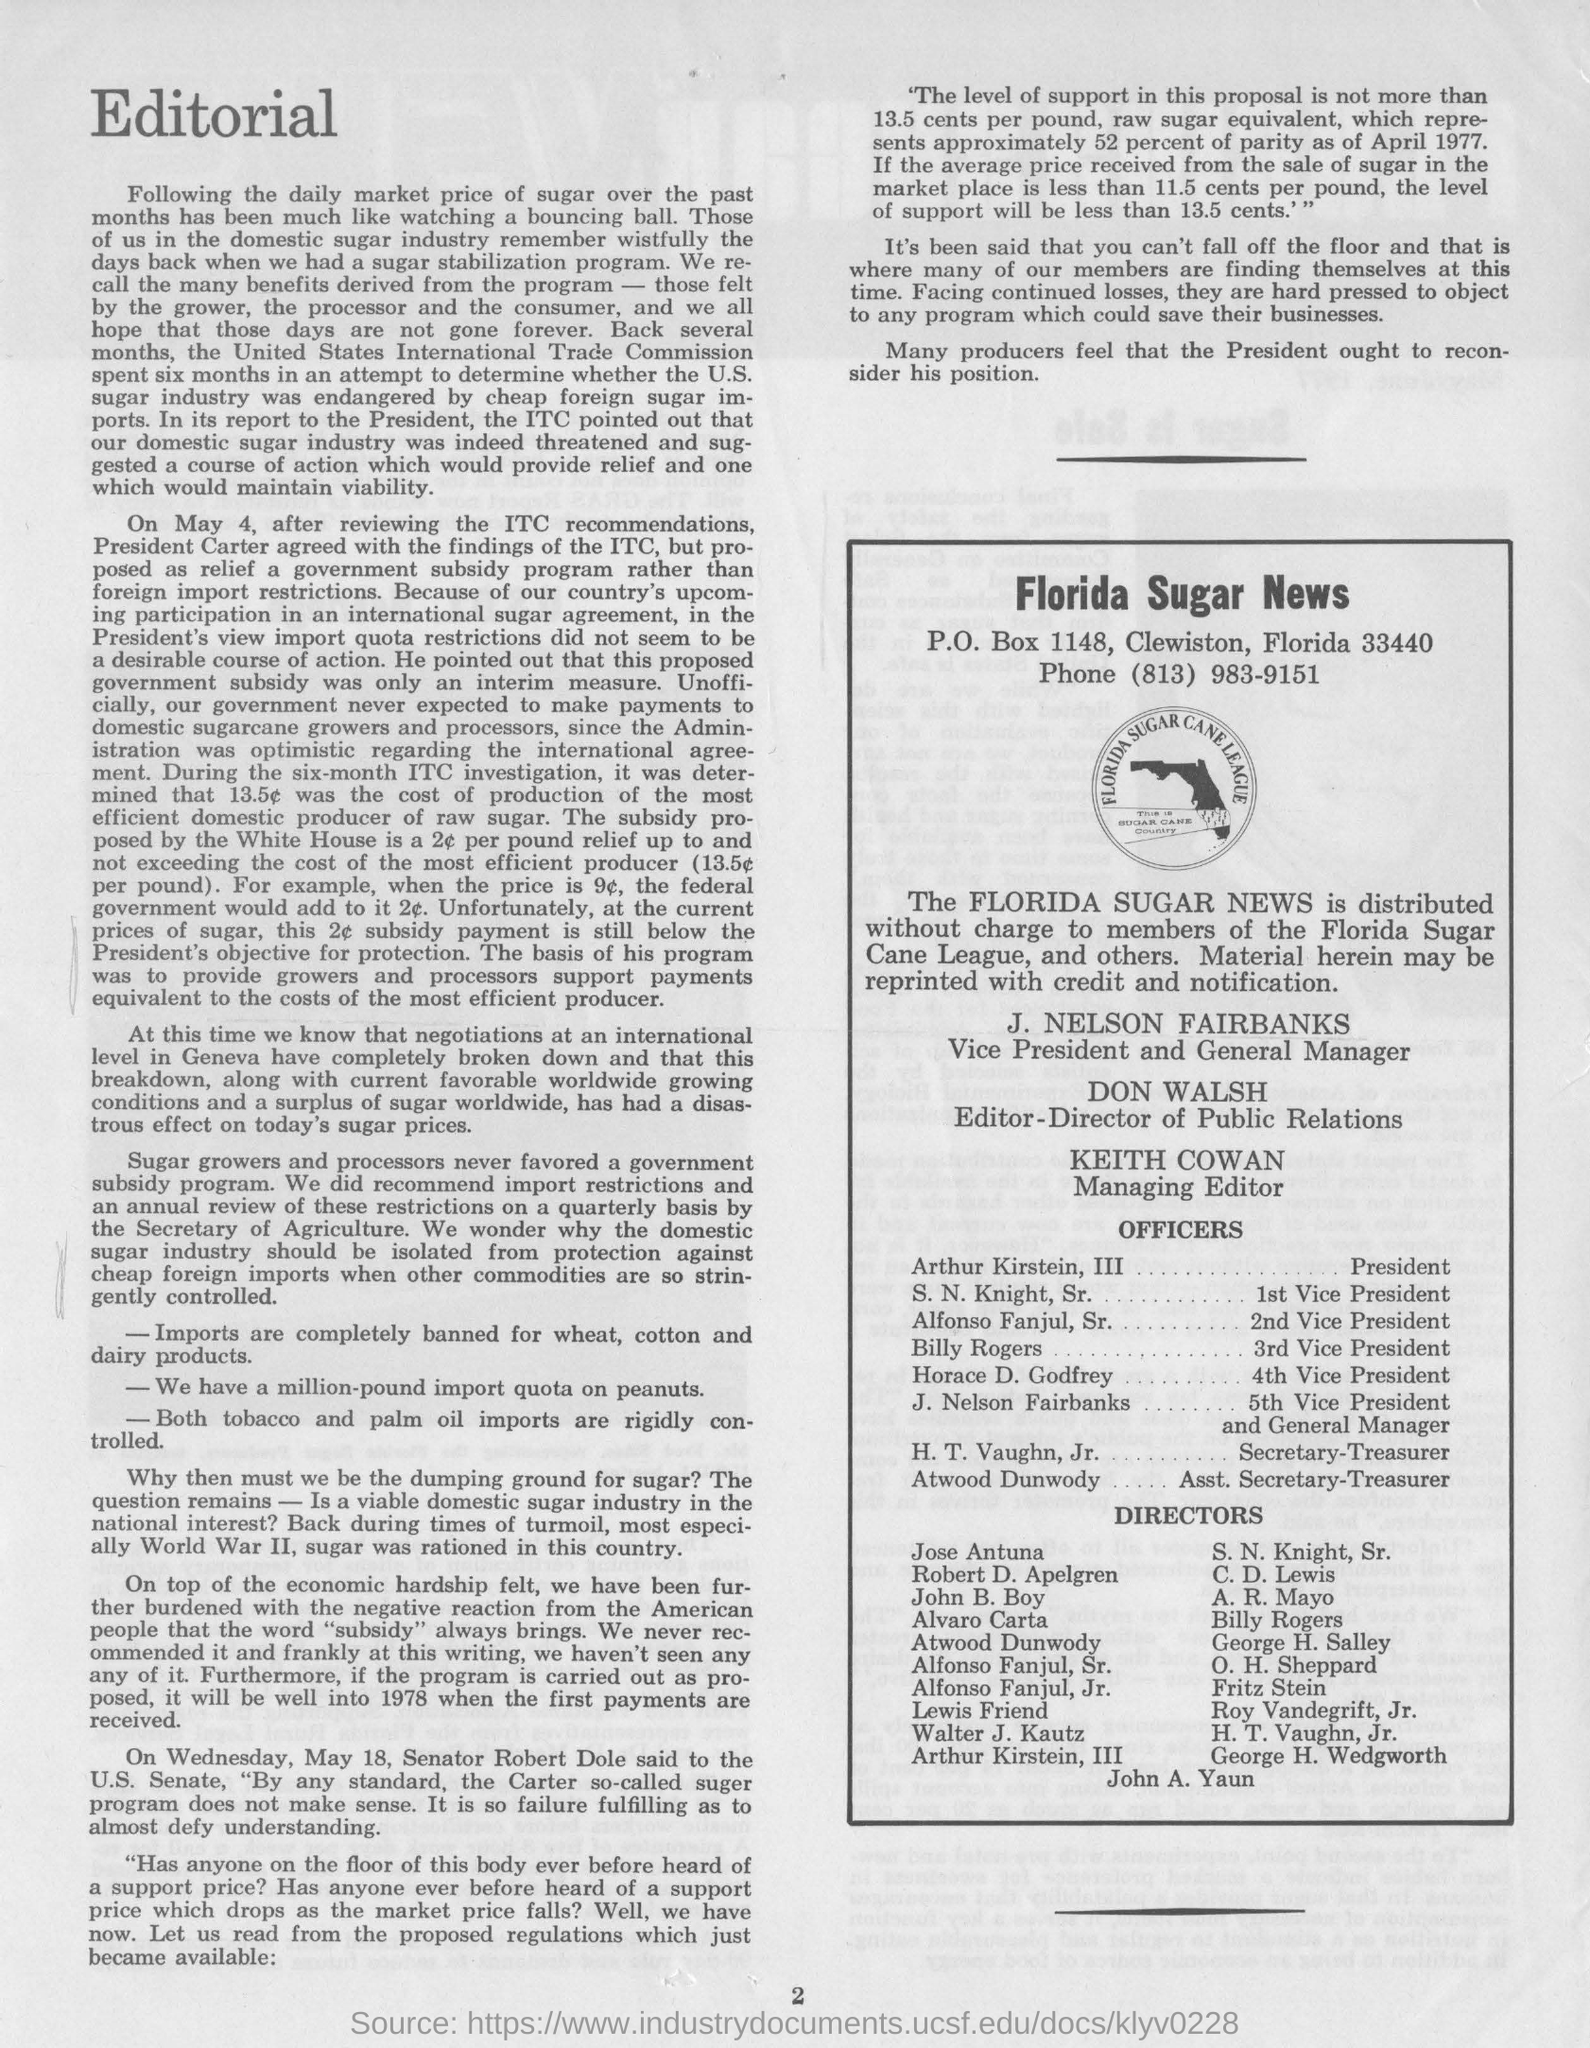What is the name of the news mentioned ?
Your answer should be compact. Florida Sugar. What is the p.o.box no. mentioned ?
Ensure brevity in your answer.  1148. What is the phone no. mentioned ?
Give a very brief answer. (813) 983-9151. What is the name of vice president and general manager mentioned ?
Offer a very short reply. J. Nelson Fairbanks. What is the name of editor-director of public relations ?
Your response must be concise. Don Walsh. What is the name of the managing editor mentioned ?
Give a very brief answer. Keith cowan. 